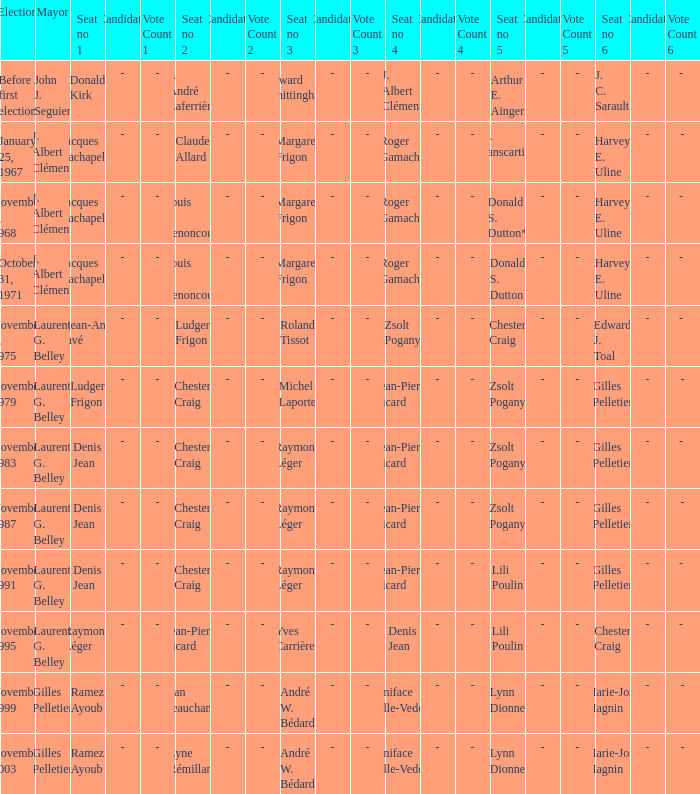Who was seat no 6 when seat no 1 and seat no 5 were jacques lachapelle and donald s. dutton Harvey E. Uline. 